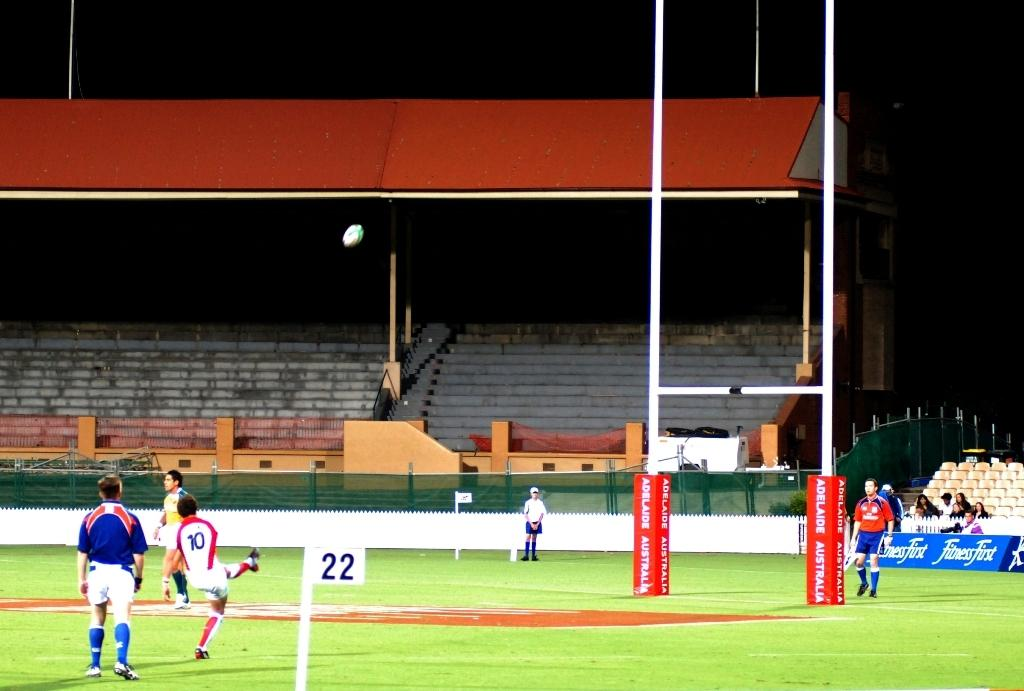What is the main feature in the center of the image? There are stairs in the center of the image. What type of material is present in the image? There is a mesh, boards, and poles in the image. Are there any people in the image? Yes, there are persons in the image. What object can be seen in the image that is typically used for playing? A ball is present in the image. What can be seen at the bottom of the image? The ground is visible at the bottom of the image. What is the lighting condition at the top of the image? The top of the image is dark. What type of advice is being given by the sofa in the image? There is no sofa present in the image, so it cannot provide any advice. 